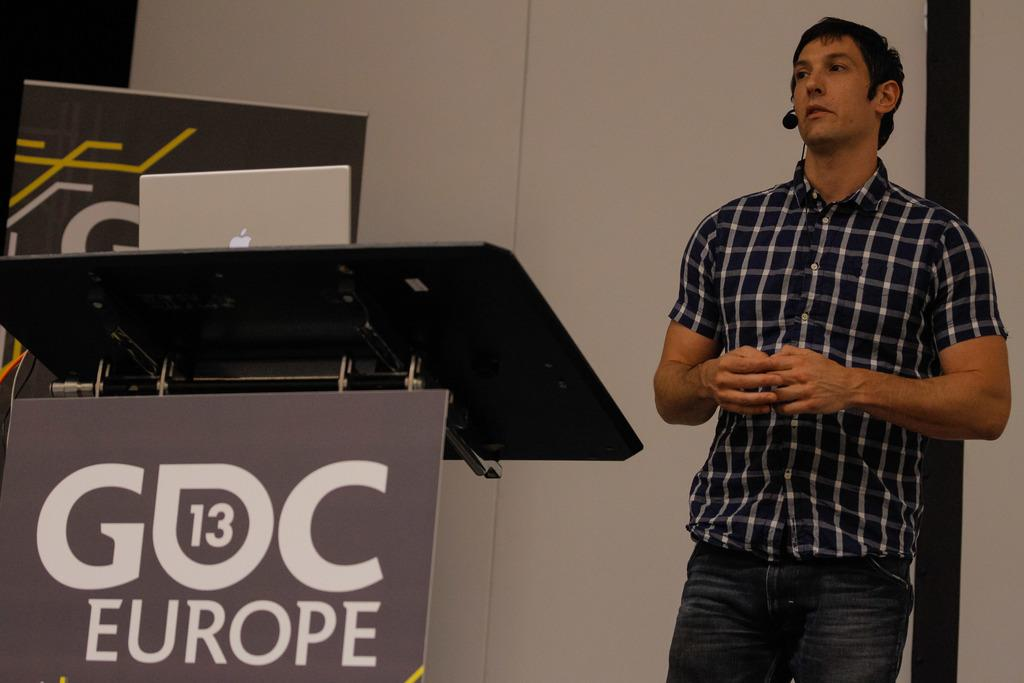Who is present in the image? There is a person in the image. What is the person doing in the image? The person is talking to a microphone. What object can be seen on the table in the image? A laptop is placed on the table. What might the person be using the laptop for while talking to the microphone? The person might be using the laptop for recording, streaming, or presenting information during their talk. What type of corn is being served for dinner in the image? There is no corn or dinner present in the image; it features a person talking to a microphone with a laptop on a table. 